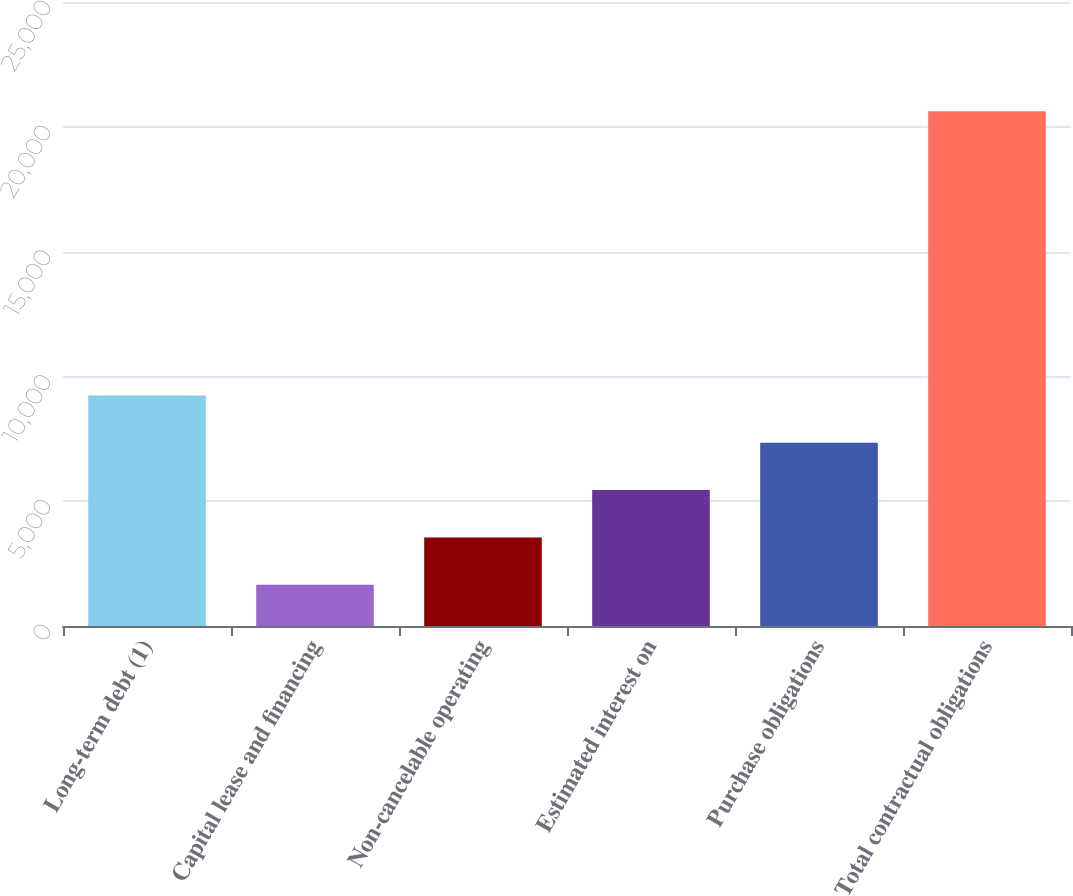<chart> <loc_0><loc_0><loc_500><loc_500><bar_chart><fcel>Long-term debt (1)<fcel>Capital lease and financing<fcel>Non-cancelable operating<fcel>Estimated interest on<fcel>Purchase obligations<fcel>Total contractual obligations<nl><fcel>9238<fcel>1650<fcel>3547<fcel>5444<fcel>7341<fcel>20620<nl></chart> 